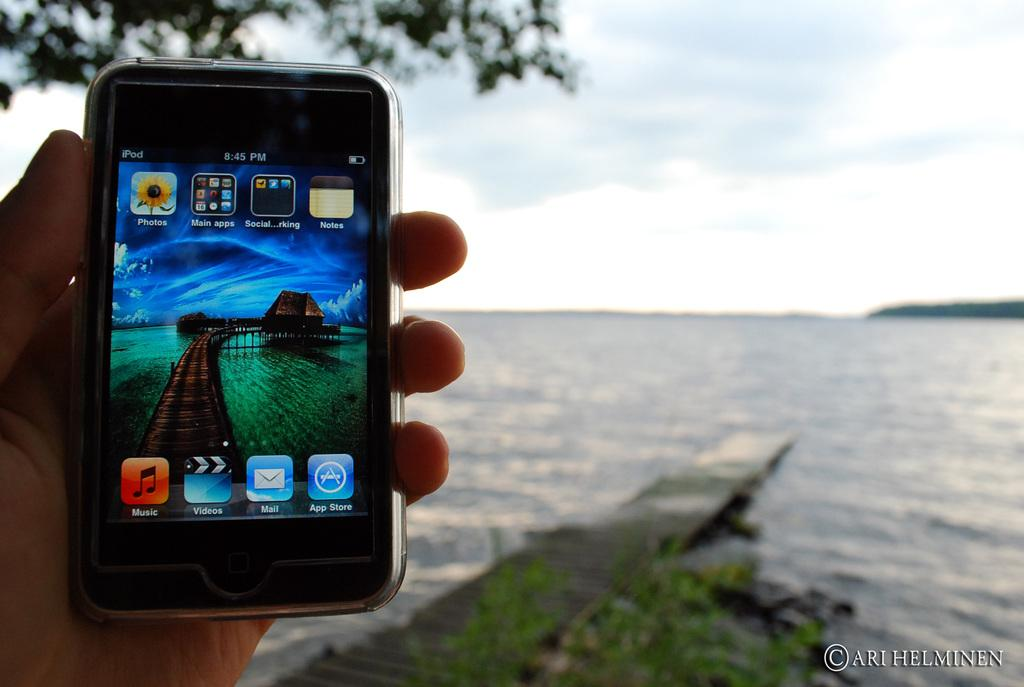<image>
Share a concise interpretation of the image provided. A hand holding a cellphone with one of the icons saying Music 